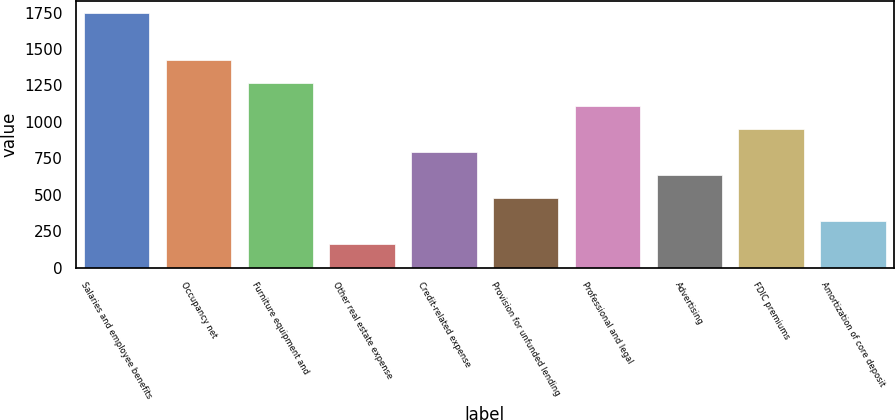<chart> <loc_0><loc_0><loc_500><loc_500><bar_chart><fcel>Salaries and employee benefits<fcel>Occupancy net<fcel>Furniture equipment and<fcel>Other real estate expense<fcel>Credit-related expense<fcel>Provision for unfunded lending<fcel>Professional and legal<fcel>Advertising<fcel>FDIC premiums<fcel>Amortization of core deposit<nl><fcel>1743.79<fcel>1426.81<fcel>1268.32<fcel>158.89<fcel>792.85<fcel>475.87<fcel>1109.83<fcel>634.36<fcel>951.34<fcel>317.38<nl></chart> 